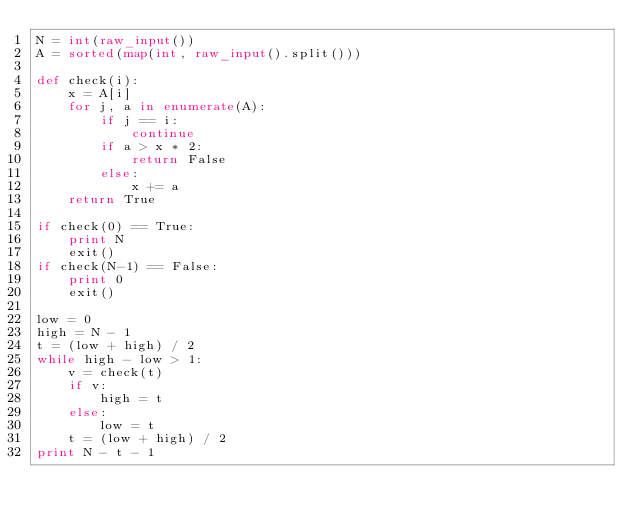<code> <loc_0><loc_0><loc_500><loc_500><_Python_>N = int(raw_input())
A = sorted(map(int, raw_input().split()))

def check(i):
    x = A[i]
    for j, a in enumerate(A):
        if j == i:
            continue
        if a > x * 2:
            return False
        else:
            x += a
    return True

if check(0) == True:
    print N
    exit()
if check(N-1) == False:
    print 0
    exit()

low = 0
high = N - 1
t = (low + high) / 2
while high - low > 1:
    v = check(t)
    if v:
        high = t
    else:
        low = t
    t = (low + high) / 2
print N - t - 1
</code> 